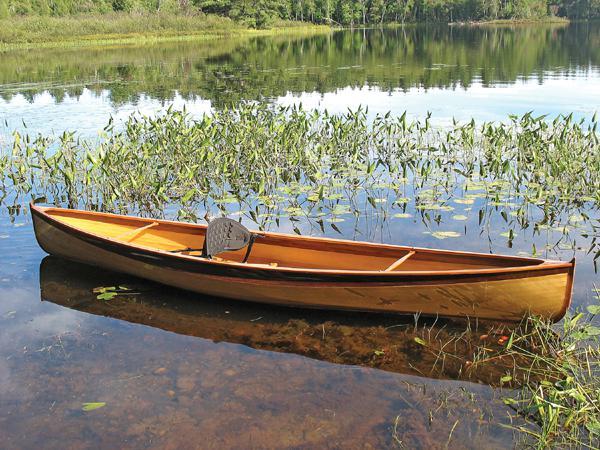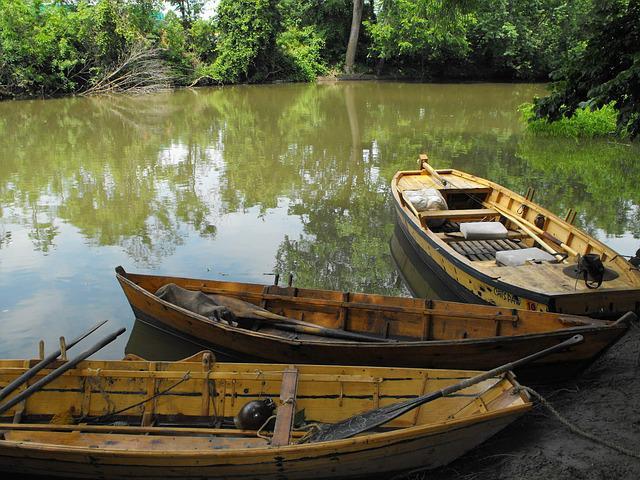The first image is the image on the left, the second image is the image on the right. For the images shown, is this caption "An image shows exactly one canoe sitting in the water." true? Answer yes or no. Yes. The first image is the image on the left, the second image is the image on the right. Analyze the images presented: Is the assertion "The left image shows one or more people inside a brown canoe that has a green top visible on it" valid? Answer yes or no. No. 